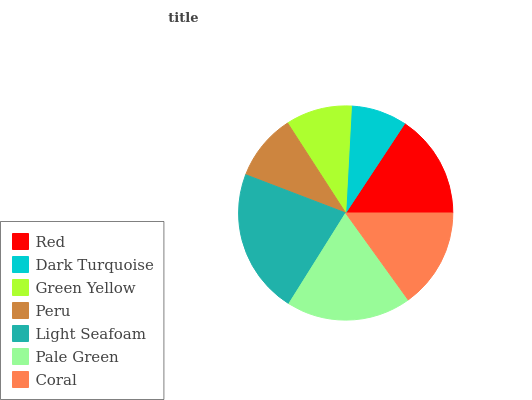Is Dark Turquoise the minimum?
Answer yes or no. Yes. Is Light Seafoam the maximum?
Answer yes or no. Yes. Is Green Yellow the minimum?
Answer yes or no. No. Is Green Yellow the maximum?
Answer yes or no. No. Is Green Yellow greater than Dark Turquoise?
Answer yes or no. Yes. Is Dark Turquoise less than Green Yellow?
Answer yes or no. Yes. Is Dark Turquoise greater than Green Yellow?
Answer yes or no. No. Is Green Yellow less than Dark Turquoise?
Answer yes or no. No. Is Coral the high median?
Answer yes or no. Yes. Is Coral the low median?
Answer yes or no. Yes. Is Peru the high median?
Answer yes or no. No. Is Light Seafoam the low median?
Answer yes or no. No. 